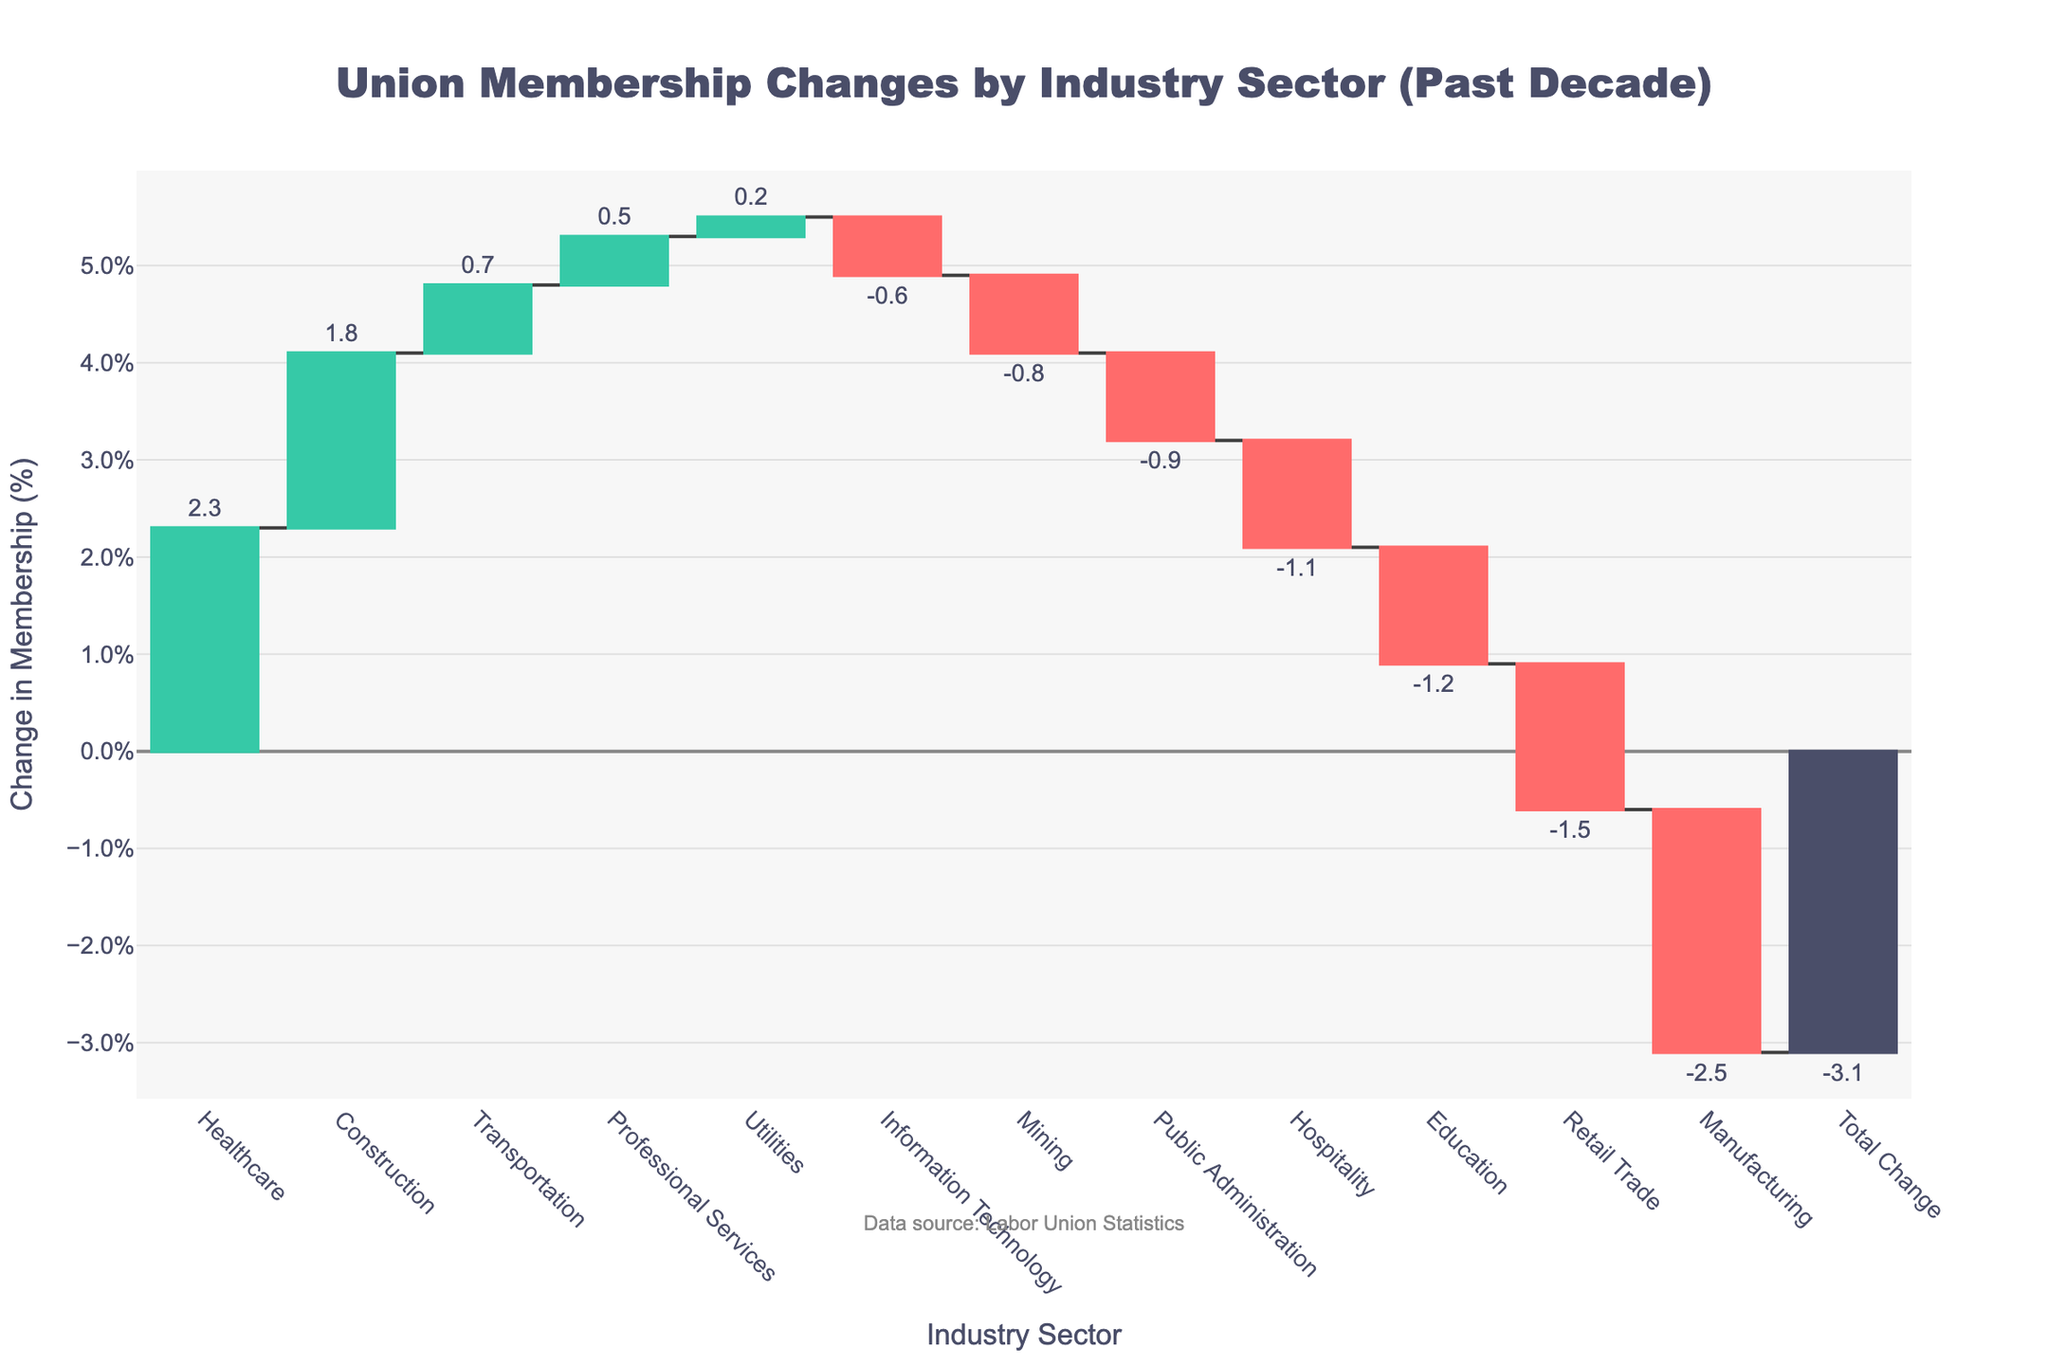What's the title of the chart? The title is usually displayed at the top of the figure. The title here reads "Union Membership Changes by Industry Sector (Past Decade)."
Answer: Union Membership Changes by Industry Sector (Past Decade) Which industry sector saw the largest increase in union membership? By observing the waterfall chart, the bar that extends the highest in the positive direction indicates the sector with the largest increase. This is Healthcare.
Answer: Healthcare What is the total change in union membership over the past decade? The total change is shown as the last bar on the waterfall chart, typically labeled "Total Change" and summed separately from individual sectors. This bar shows a change of -3.1%.
Answer: -3.1% Which industry sector had the largest decrease in union membership? The largest decrease is represented by the bar that extends the most in the negative direction. This is Manufacturing.
Answer: Manufacturing How did union membership in the Education sector change over the past decade? We look for the bar labeled "Education" on the x-axis and observe its height and color to determine the change. The bar for Education shows a decrease of -1.2%.
Answer: -1.2% Compare the changes in union membership between the Construction and Information Technology sectors. By comparing the heights of the bars for Construction and Information Technology on the x-axis, Construction shows an increase of 1.8%, whereas Information Technology shows a decrease of -0.6%.
Answer: Construction: 1.8%, Information Technology: -0.6% How many sectors experienced a decrease in union membership? Count the number of bars extending in the negative direction. The following sectors had decreases: Manufacturing, Education, Public Administration, Retail Trade, Information Technology, Hospitality, and Mining. This totals to seven sectors.
Answer: 7 sectors What is the combined change in union membership for the Construction and Healthcare sectors? Add the percentages for Construction (1.8%) and Healthcare (2.3%) to get the combined change. This results in 1.8% + 2.3% = 4.1%.
Answer: 4.1% Which industry sectors have minor changes (e.g., between -0.5% and 0.5%) in union membership? Identify the bars that fall within the range of -0.5% to 0.5%. The sectors here are Utilities (0.2%) and Professional Services (0.5%).
Answer: Utilities and Professional Services What proportion of the sectors showed an increase in union membership? Count the number of sectors with bars extending in the positive direction and divide by the total number of sectors (excluding "Total Change"). Healthcare, Construction, Transportation, and Professional Services showed increases, totaling four sectors. There are 12 sectors in total (excluding "Total Change"). The proportion is 4/12.
Answer: 1/3 